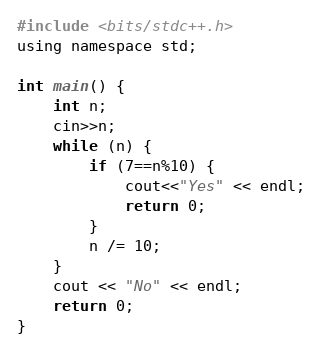Convert code to text. <code><loc_0><loc_0><loc_500><loc_500><_C_>#include <bits/stdc++.h>
using namespace std;

int main() {
    int n;
    cin>>n;
    while (n) {
        if (7==n%10) {
            cout<<"Yes" << endl;
            return 0;
        }
        n /= 10;
    }
    cout << "No" << endl;
    return 0;
}</code> 